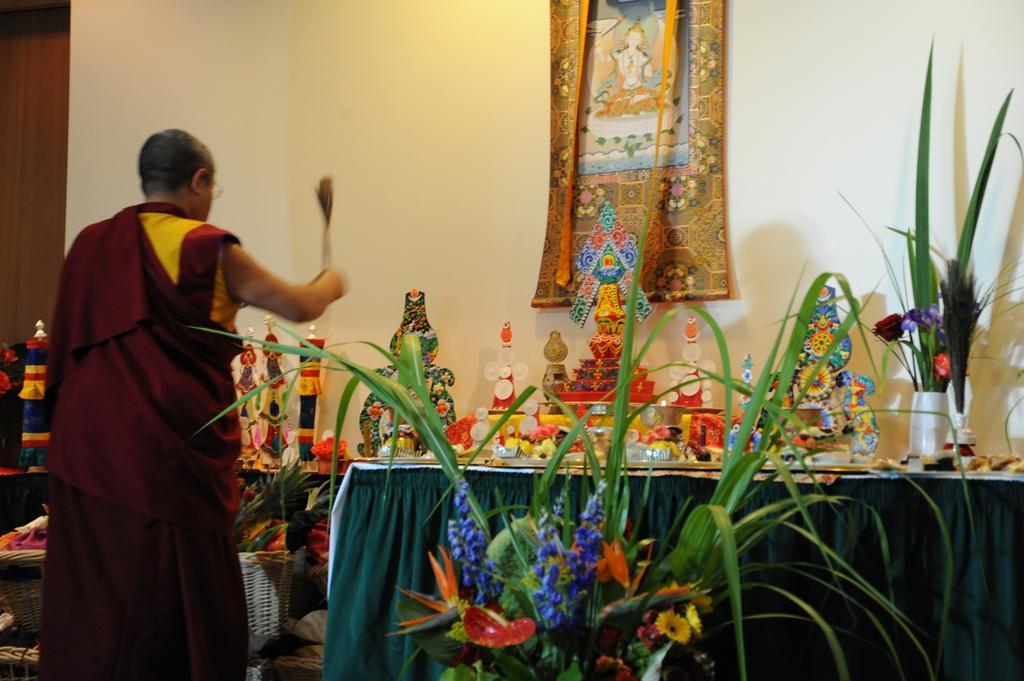Describe this image in one or two sentences. In the picture we can see a Chinese priest doing some prayers, in front of him we can see a table with blue color cloth and some plant and flower decorations to it and on the table, we can see some god sculptures and to the wall we can see some craft and beside the wall we can see a wooden door. 